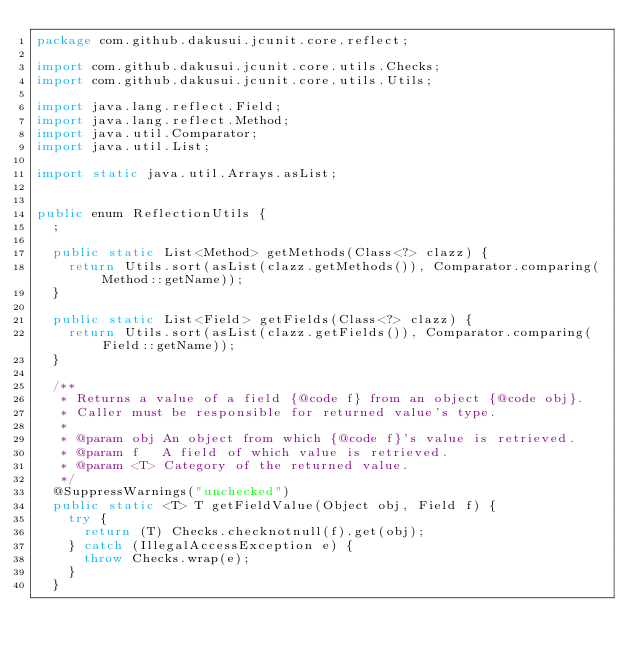<code> <loc_0><loc_0><loc_500><loc_500><_Java_>package com.github.dakusui.jcunit.core.reflect;

import com.github.dakusui.jcunit.core.utils.Checks;
import com.github.dakusui.jcunit.core.utils.Utils;

import java.lang.reflect.Field;
import java.lang.reflect.Method;
import java.util.Comparator;
import java.util.List;

import static java.util.Arrays.asList;


public enum ReflectionUtils {
  ;

  public static List<Method> getMethods(Class<?> clazz) {
    return Utils.sort(asList(clazz.getMethods()), Comparator.comparing(Method::getName));
  }

  public static List<Field> getFields(Class<?> clazz) {
    return Utils.sort(asList(clazz.getFields()), Comparator.comparing(Field::getName));
  }

  /**
   * Returns a value of a field {@code f} from an object {@code obj}.
   * Caller must be responsible for returned value's type.
   *
   * @param obj An object from which {@code f}'s value is retrieved.
   * @param f   A field of which value is retrieved.
   * @param <T> Category of the returned value.
   */
  @SuppressWarnings("unchecked")
  public static <T> T getFieldValue(Object obj, Field f) {
    try {
      return (T) Checks.checknotnull(f).get(obj);
    } catch (IllegalAccessException e) {
      throw Checks.wrap(e);
    }
  }
</code> 